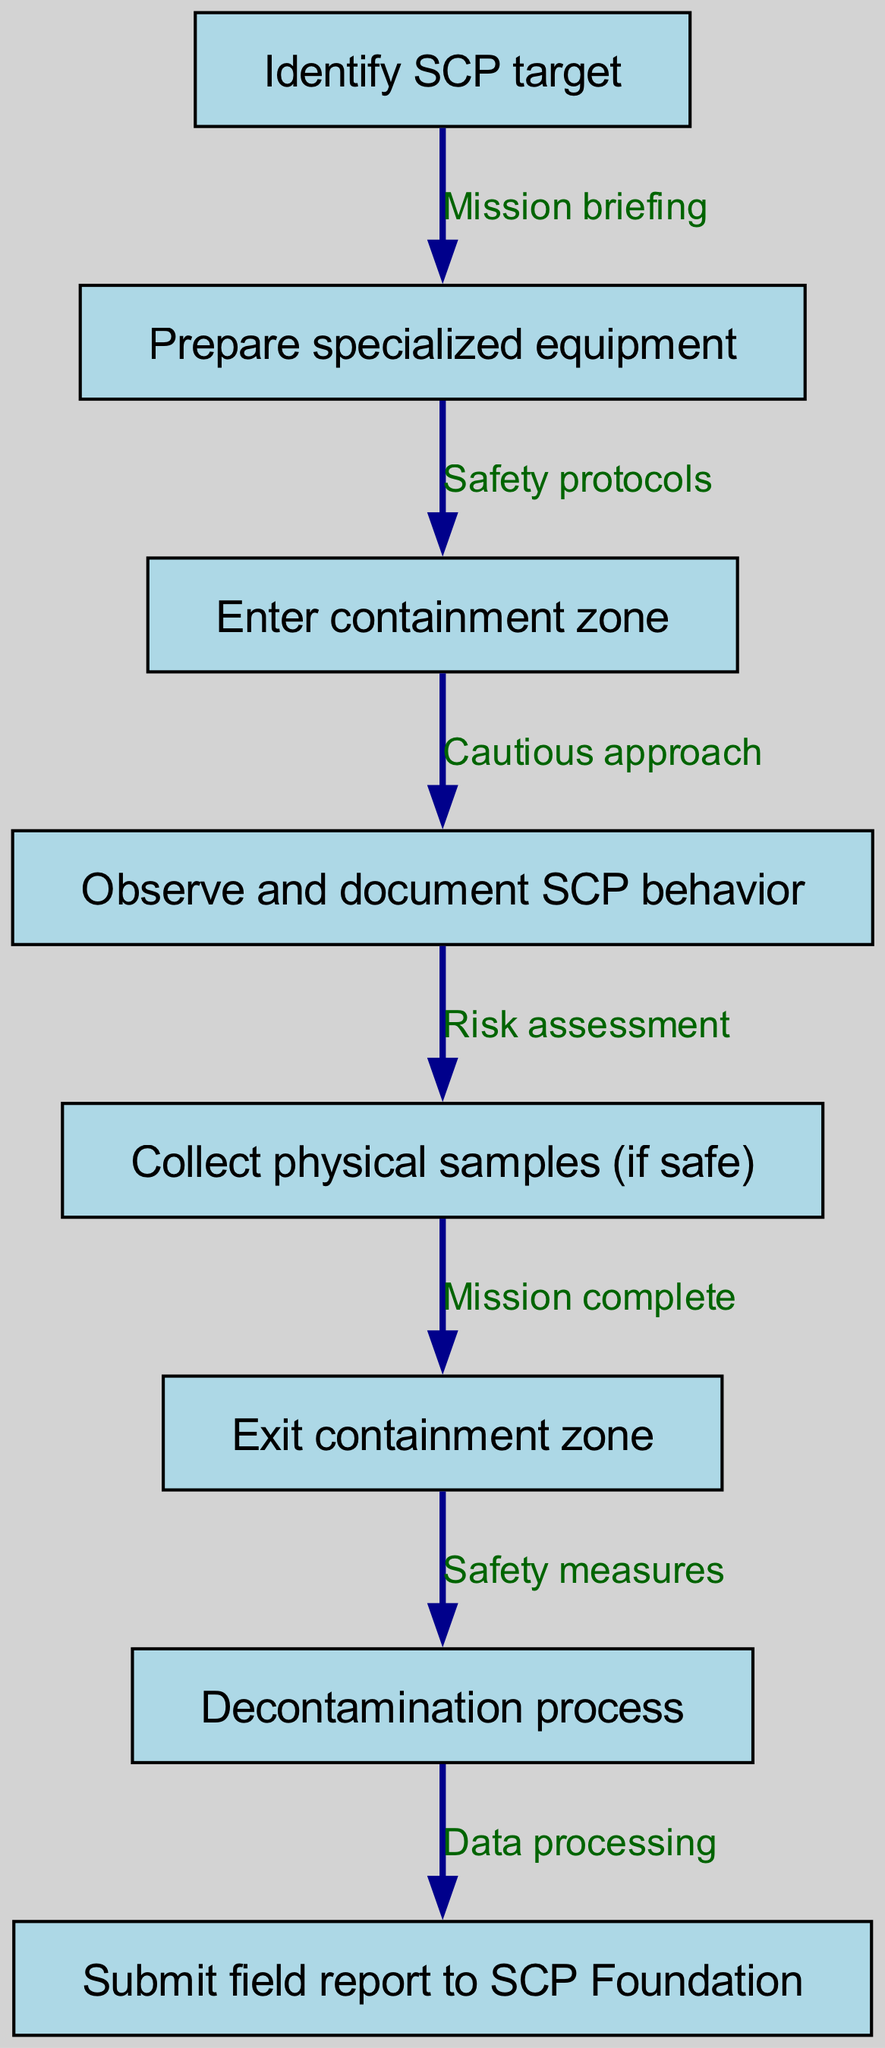What is the first step in the workflow? The diagram shows that the first step is to "Identify SCP target," which is the initial node in the sequence.
Answer: Identify SCP target How many nodes are in the flow chart? By counting the nodes listed in the diagram, there are eight nodes representing different stages of the workflow.
Answer: 8 What is the edge label between nodes 3 and 4? The edge connecting node 3 ("Enter containment zone") and node 4 ("Observe and document SCP behavior") is labeled "Cautious approach."
Answer: Cautious approach What action follows after observing and documenting SCP behavior? The next action after node 4 is to "Collect physical samples (if safe)," indicated by the edge connecting these two nodes.
Answer: Collect physical samples (if safe) What is the last node in the workflow? The last node in the workflow is "Submit field report to SCP Foundation," which is the final step after completing all prior actions.
Answer: Submit field report to SCP Foundation If physical samples are collected, what is the subsequent step? After "Collect physical samples (if safe)," the next step is "Exit containment zone," as shown in the diagram following this node.
Answer: Exit containment zone What are the safety measures mentioned before submission of the field report? The safety measures refer to the "Decontamination process," which is the step that leads directly to submitting the field report to ensure safety after the mission.
Answer: Decontamination process Which two nodes are directly connected by the edge labeled "Mission complete"? The nodes directly connected by "Mission complete" are node 5 ("Collect physical samples (if safe)") and node 6 ("Exit containment zone").
Answer: Collect physical samples (if safe) and Exit containment zone What is the overall purpose of the workflow illustrated in the diagram? The purpose of the workflow is to outline the systematic process of collecting and reporting field observations of SCP entities, ensuring safety and thorough documentation.
Answer: Data collection and reporting 